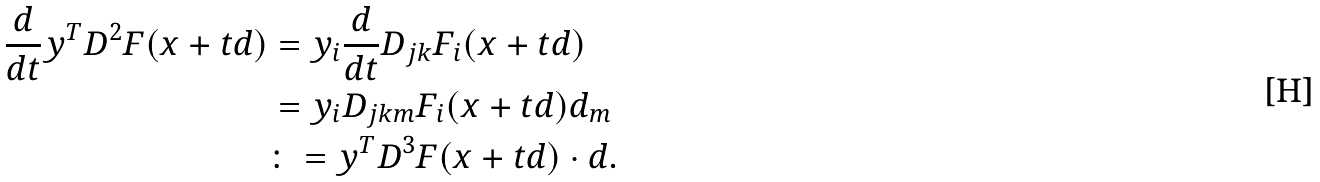<formula> <loc_0><loc_0><loc_500><loc_500>\frac { d } { d t } y ^ { T } D ^ { 2 } F ( x + t d ) & = y _ { i } \frac { d } { d t } D _ { j k } F _ { i } ( x + t d ) \\ & = y _ { i } D _ { j k m } F _ { i } ( x + t d ) d _ { m } \\ & \colon = y ^ { T } D ^ { 3 } F ( x + t d ) \cdot d .</formula> 